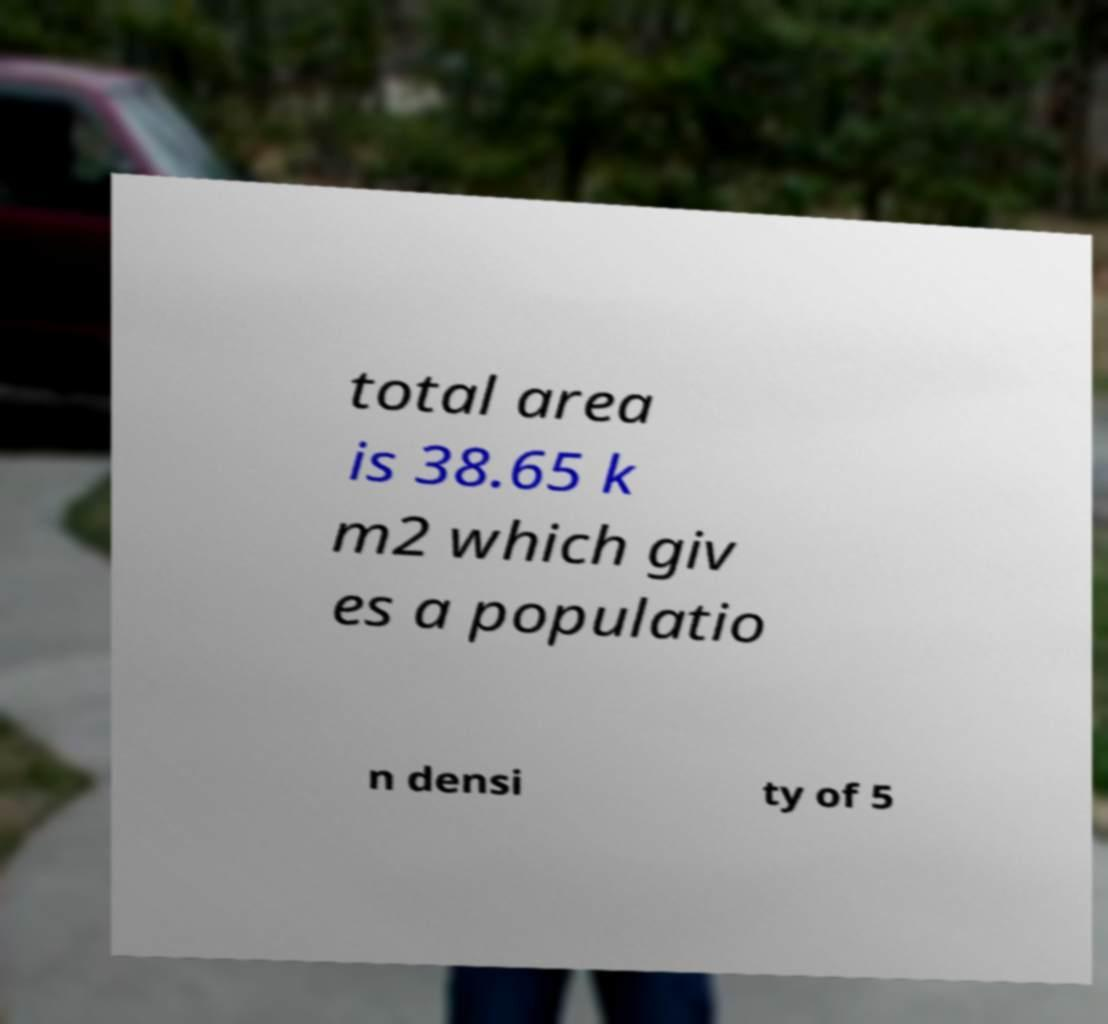There's text embedded in this image that I need extracted. Can you transcribe it verbatim? total area is 38.65 k m2 which giv es a populatio n densi ty of 5 